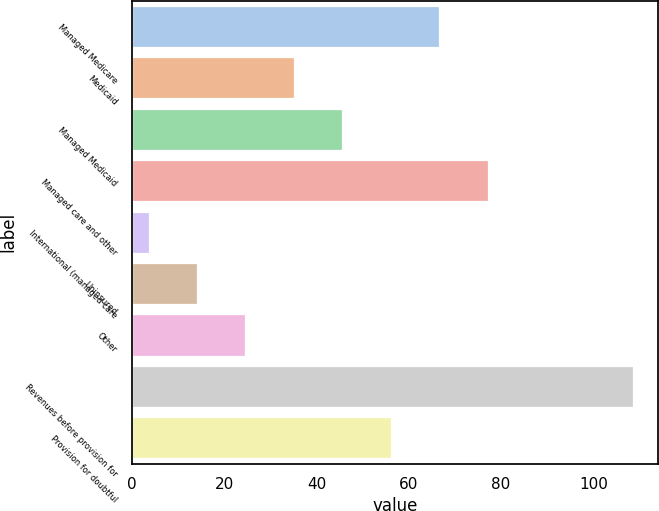<chart> <loc_0><loc_0><loc_500><loc_500><bar_chart><fcel>Managed Medicare<fcel>Medicaid<fcel>Managed Medicaid<fcel>Managed care and other<fcel>International (managed care<fcel>Uninsured<fcel>Other<fcel>Revenues before provision for<fcel>Provision for doubtful<nl><fcel>66.6<fcel>35.1<fcel>45.6<fcel>77.1<fcel>3.6<fcel>14.1<fcel>24.6<fcel>108.6<fcel>56.1<nl></chart> 